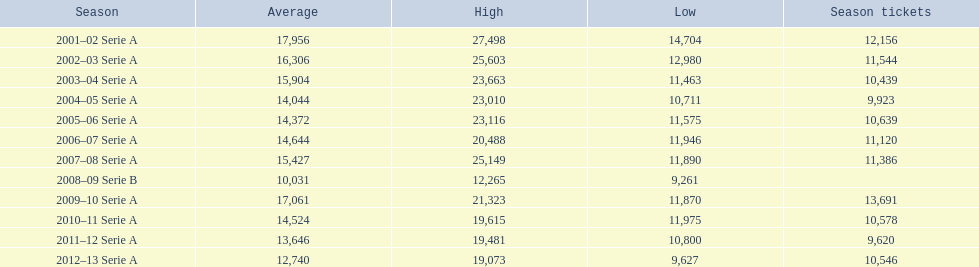What are the distinct seasons? 2001–02 Serie A, 2002–03 Serie A, 2003–04 Serie A, 2004–05 Serie A, 2005–06 Serie A, 2006–07 Serie A, 2007–08 Serie A, 2008–09 Serie B, 2009–10 Serie A, 2010–11 Serie A, 2011–12 Serie A, 2012–13 Serie A. During 2007, which season was it? 2007–08 Serie A. In that particular season, how many season passes were sold? 11,386. 